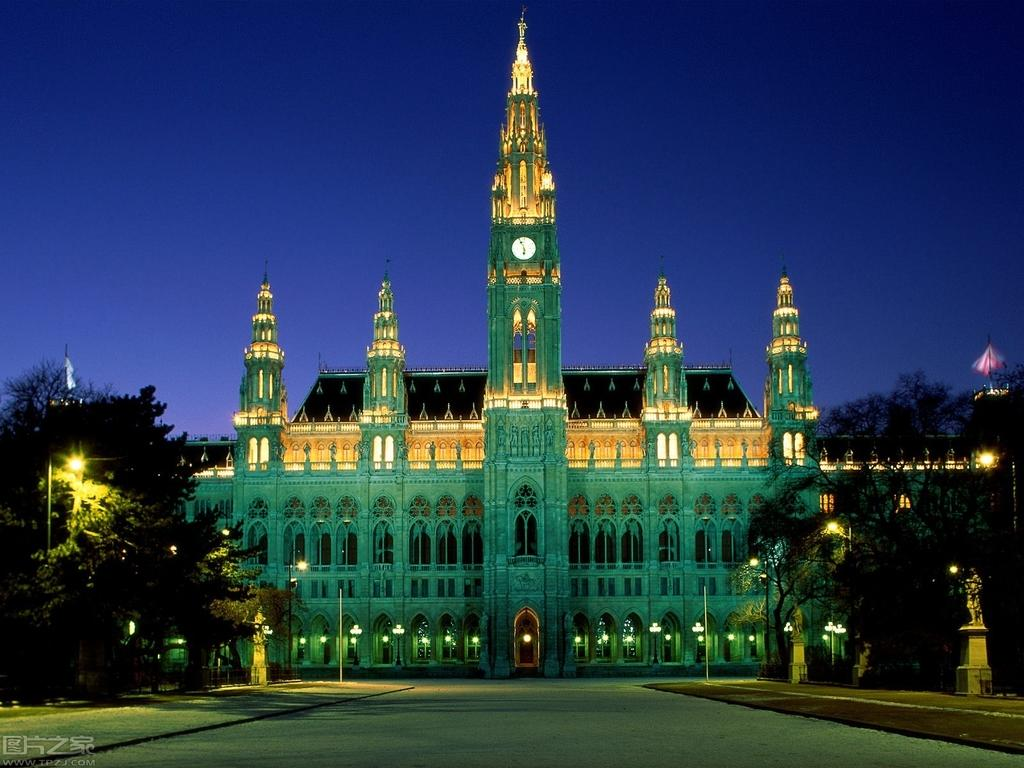What is the main structure in the center of the image? There is a building in the center of the image. What can be seen in the background of the image? There are trees, lights, and pillars in the background of the image. What is at the bottom of the image? There is a road at the bottom of the image. Can you see anyone trapped in quicksand in the image? There is no quicksand present in the image, so it is not possible to see anyone trapped in it. 